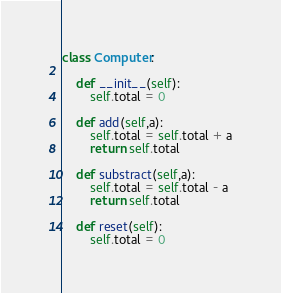Convert code to text. <code><loc_0><loc_0><loc_500><loc_500><_Python_>class Computer:

    def __init__(self):
        self.total = 0

    def add(self,a):
        self.total = self.total + a
        return self.total

    def substract(self,a):
        self.total = self.total - a
        return self.total

    def reset(self):
        self.total = 0</code> 